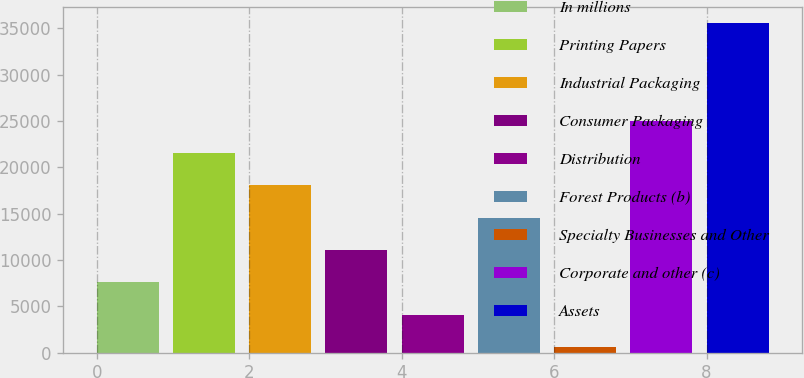Convert chart to OTSL. <chart><loc_0><loc_0><loc_500><loc_500><bar_chart><fcel>In millions<fcel>Printing Papers<fcel>Industrial Packaging<fcel>Consumer Packaging<fcel>Distribution<fcel>Forest Products (b)<fcel>Specialty Businesses and Other<fcel>Corporate and other (c)<fcel>Assets<nl><fcel>7605.8<fcel>21565.4<fcel>18075.5<fcel>11095.7<fcel>4115.9<fcel>14585.6<fcel>626<fcel>25055.3<fcel>35525<nl></chart> 